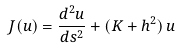<formula> <loc_0><loc_0><loc_500><loc_500>J ( u ) = \frac { d ^ { 2 } u } { d s ^ { 2 } } + ( K + h ^ { 2 } ) \, u</formula> 